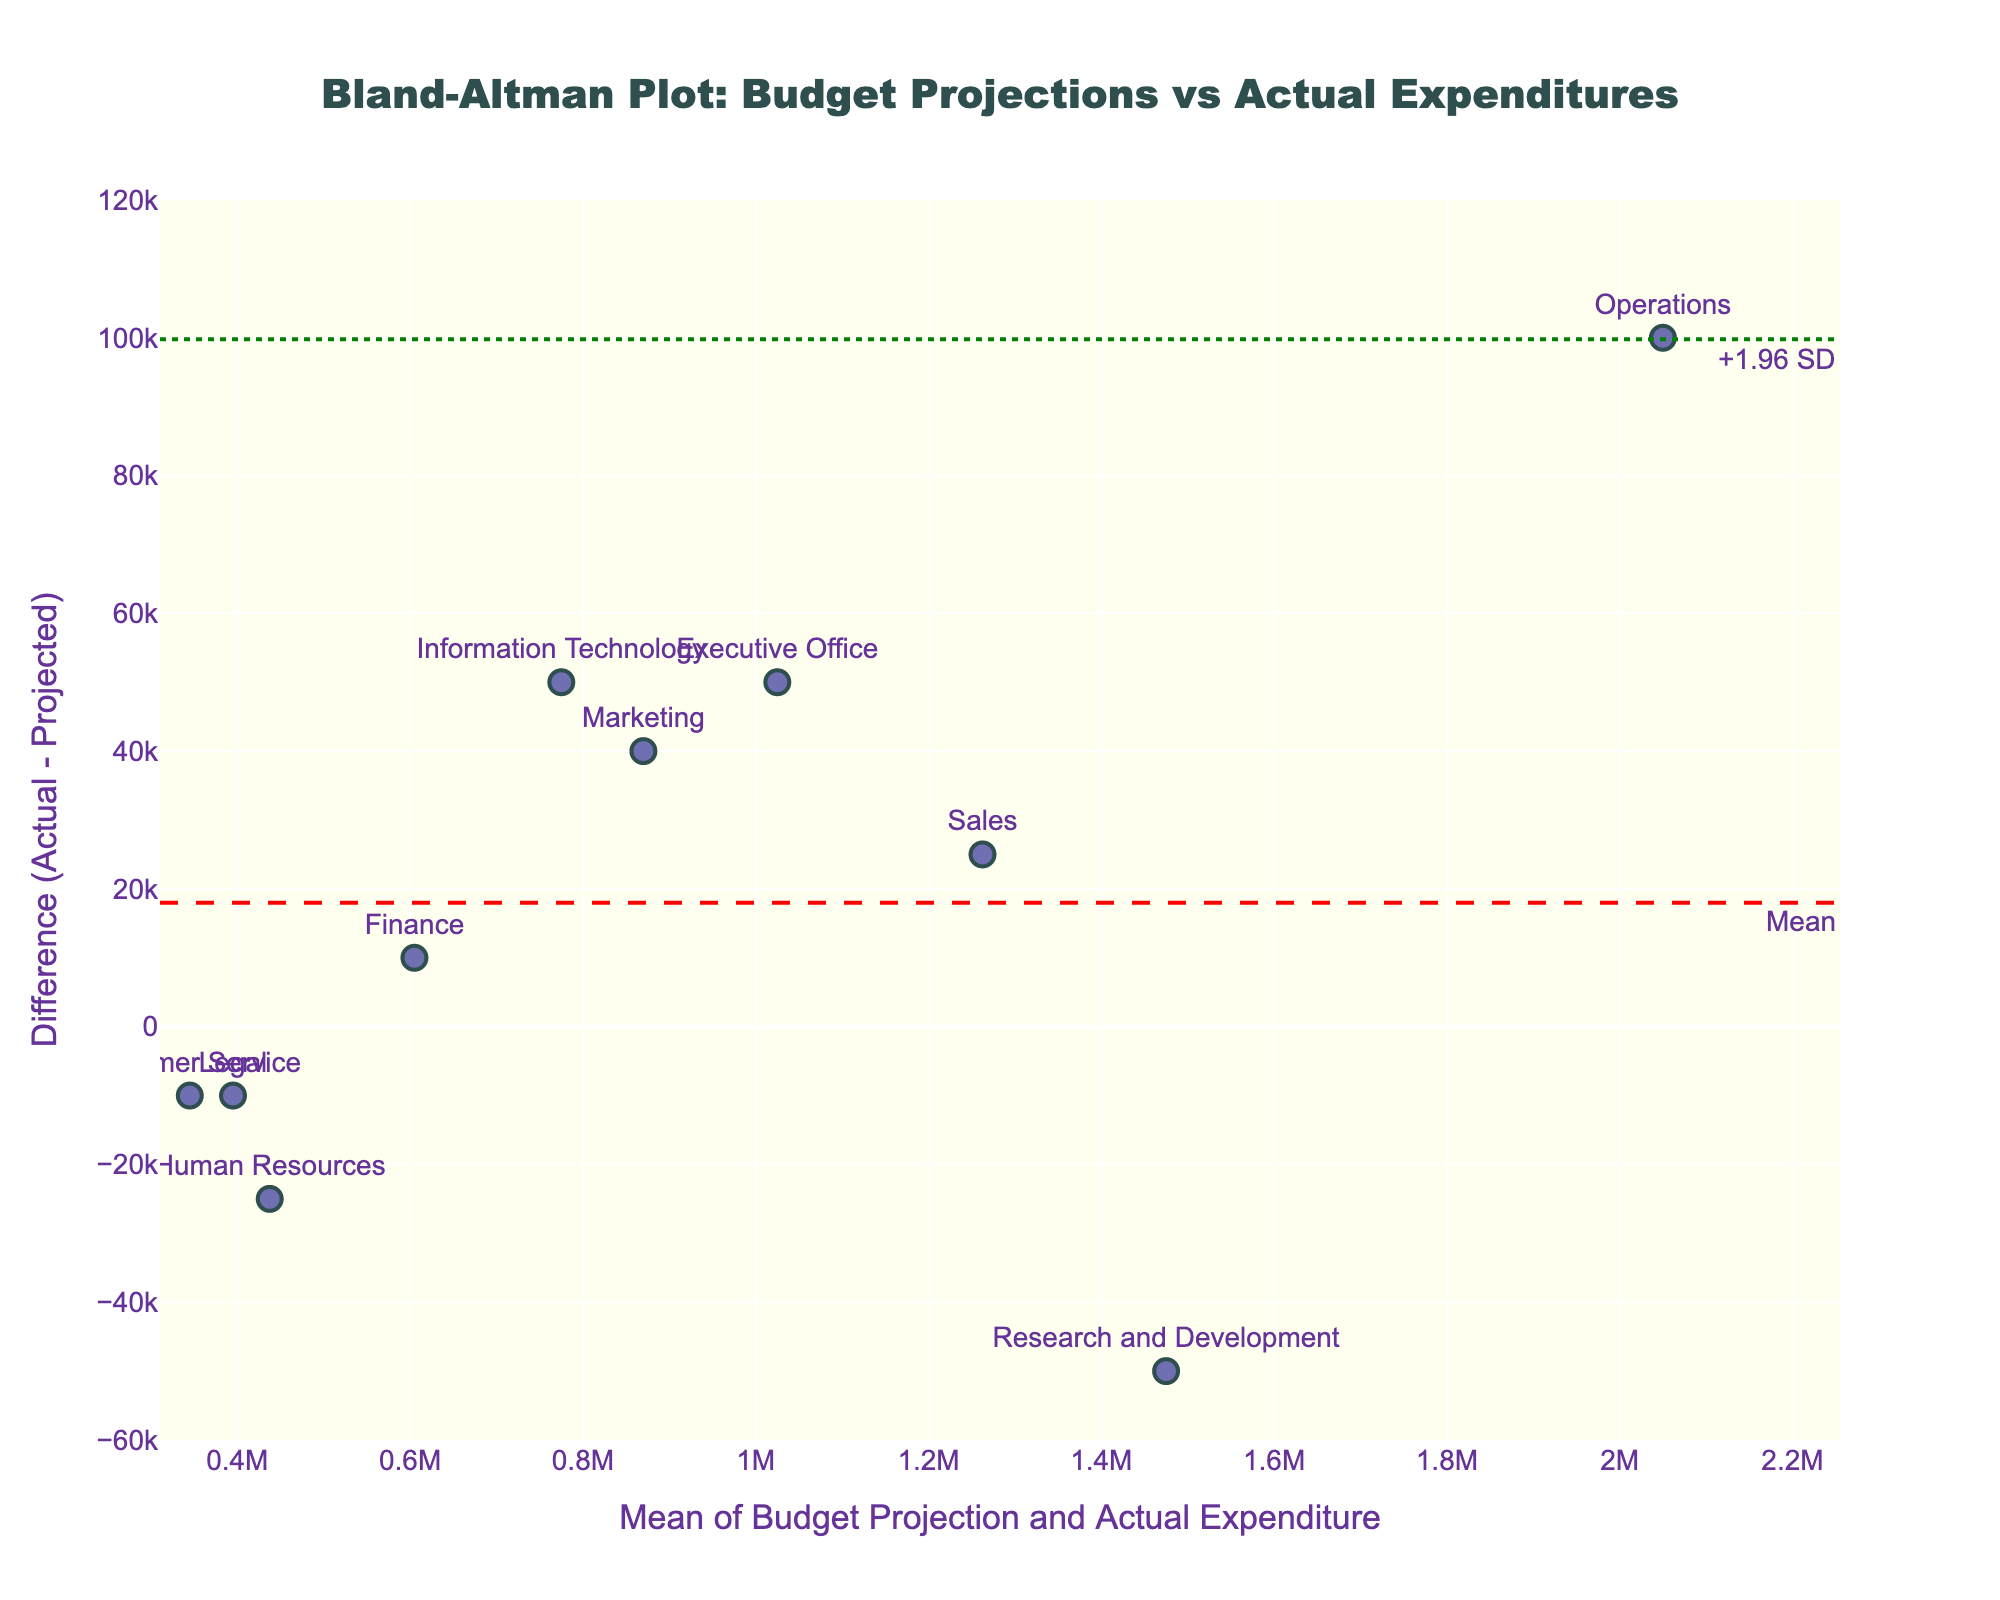What is the title of the plot? The title is located at the top center of the plot. It is indicated with larger font size and bold text.
Answer: Bland-Altman Plot: Budget Projections vs Actual Expenditures How many departments are represented in the plot? Count the number of data points, each of which represents a department. Each data point has an associated label.
Answer: 10 Which department has the largest positive difference between actual expenditure and budget projection? Identify the department with the highest point on the y-axis. The largest positive difference will be the highest vertical distance from the zero line (mean difference).
Answer: Operations What is the mean difference (Actual - Projected) value? The mean difference is indicated by the red dashed horizontal line. The value is often annotated near the line.
Answer: It corresponds to the red dashed line marked "Mean" What are the upper and lower limits of agreement? The upper and lower limits of agreement are represented by the green dotted lines. They are annotated as "+1.96 SD" and "-1.96 SD".
Answer: Upper limit: +1.96 SD, Lower limit: -1.96 SD Is there any department whose actual expenditure was exactly equal to its budget projection? Look for any data point where the difference value on the y-axis is zero. If there is no point on the zero line, there is no exact match.
Answer: No Which department has the smallest difference (either positive or negative) between actual expenditure and budget projection? Identify the data point closest to the zero line on the y-axis.
Answer: Finance How are the mean of budget projections and actual expenditures represented on the x-axis? The x-axis represents the mean of the Budget Projection and Actual Expenditure for each department. It is the average of these two values.
Answer: Mean of Budget Projection and Actual Expenditure How does the actual expenditure of the Marketing department compare to its budget projection? Identify the data point labeled "Marketing" and determine the position relative to the zero line. Higher means actual expenditure is greater; lower means it is less.
Answer: Actual expenditure is higher Which departments have actual expenditures less than budget projections? Identify all data points lying below the zero line (negative difference). The names of these departments will be displayed near these points.
Answer: Human Resources, Research and Development, Customer Service, Legal 